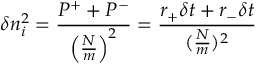<formula> <loc_0><loc_0><loc_500><loc_500>\delta n _ { i } ^ { 2 } = \frac { P ^ { + } + P ^ { - } } { \left ( \frac { N } { m } \right ) ^ { 2 } } = \frac { r _ { + } \delta t + r _ { - } \delta t } { ( \frac { N } { m } ) ^ { 2 } }</formula> 